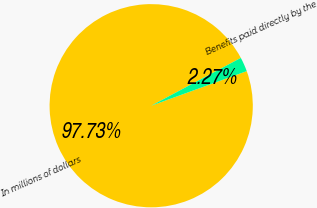<chart> <loc_0><loc_0><loc_500><loc_500><pie_chart><fcel>In millions of dollars<fcel>Benefits paid directly by the<nl><fcel>97.73%<fcel>2.27%<nl></chart> 